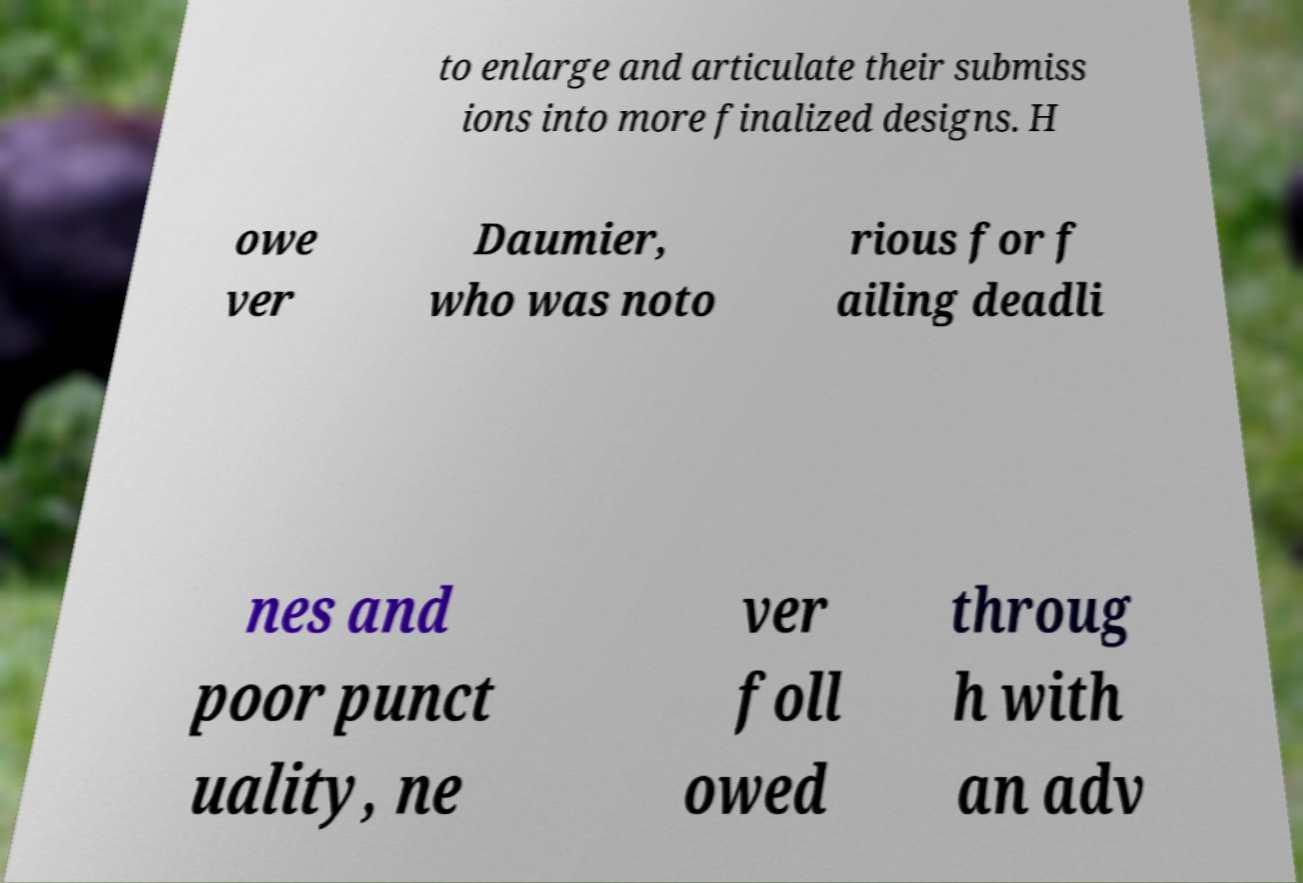For documentation purposes, I need the text within this image transcribed. Could you provide that? to enlarge and articulate their submiss ions into more finalized designs. H owe ver Daumier, who was noto rious for f ailing deadli nes and poor punct uality, ne ver foll owed throug h with an adv 